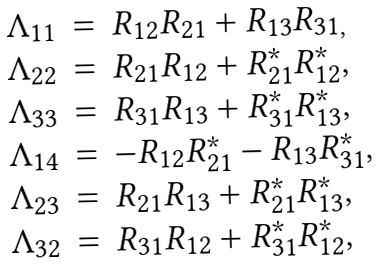<formula> <loc_0><loc_0><loc_500><loc_500>\begin{array} { r c l } \Lambda _ { 1 1 } & = & R _ { 1 2 } R _ { 2 1 } + R _ { 1 3 } R _ { 3 1 , } \\ \Lambda _ { 2 2 } & = & R _ { 2 1 } R _ { 1 2 } + R _ { 2 1 } ^ { * } R _ { 1 2 } ^ { * } , \\ \Lambda _ { 3 3 } & = & R _ { 3 1 } R _ { 1 3 } + R _ { 3 1 } ^ { * } R _ { 1 3 } ^ { * } , \\ \Lambda _ { 1 4 } & = & - R _ { 1 2 } R _ { 2 1 } ^ { * } - R _ { 1 3 } R _ { 3 1 } ^ { * } , \\ \Lambda _ { 2 3 } & = & R _ { 2 1 } R _ { 1 3 } + R _ { 2 1 } ^ { * } R _ { 1 3 } ^ { * } , \\ \Lambda _ { 3 2 } & = & R _ { 3 1 } R _ { 1 2 } + R _ { 3 1 } ^ { * } R _ { 1 2 } ^ { * } , \end{array}</formula> 